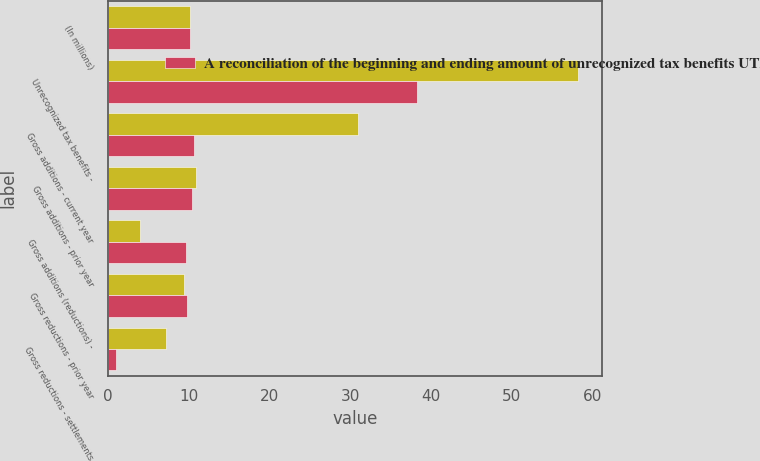Convert chart to OTSL. <chart><loc_0><loc_0><loc_500><loc_500><stacked_bar_chart><ecel><fcel>(In millions)<fcel>Unrecognized tax benefits -<fcel>Gross additions - current year<fcel>Gross additions - prior year<fcel>Gross additions (reductions) -<fcel>Gross reductions - prior year<fcel>Gross reductions - settlements<nl><fcel>nan<fcel>10.1<fcel>58.2<fcel>31<fcel>10.9<fcel>4<fcel>9.4<fcel>7.2<nl><fcel>A reconciliation of the beginning and ending amount of unrecognized tax benefits UTBs was as follows<fcel>10.1<fcel>38.2<fcel>10.7<fcel>10.4<fcel>9.7<fcel>9.8<fcel>1<nl></chart> 